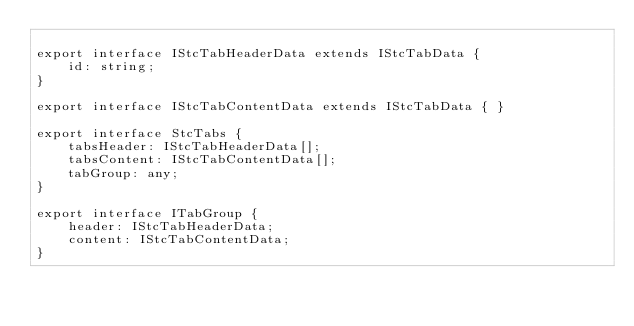Convert code to text. <code><loc_0><loc_0><loc_500><loc_500><_TypeScript_>
export interface IStcTabHeaderData extends IStcTabData {
    id: string;
}

export interface IStcTabContentData extends IStcTabData { }

export interface StcTabs {
    tabsHeader: IStcTabHeaderData[];
    tabsContent: IStcTabContentData[];
    tabGroup: any;
}

export interface ITabGroup {
    header: IStcTabHeaderData;
    content: IStcTabContentData;
}</code> 